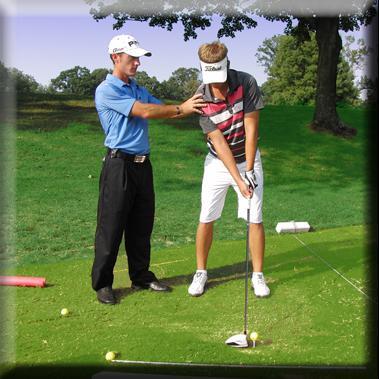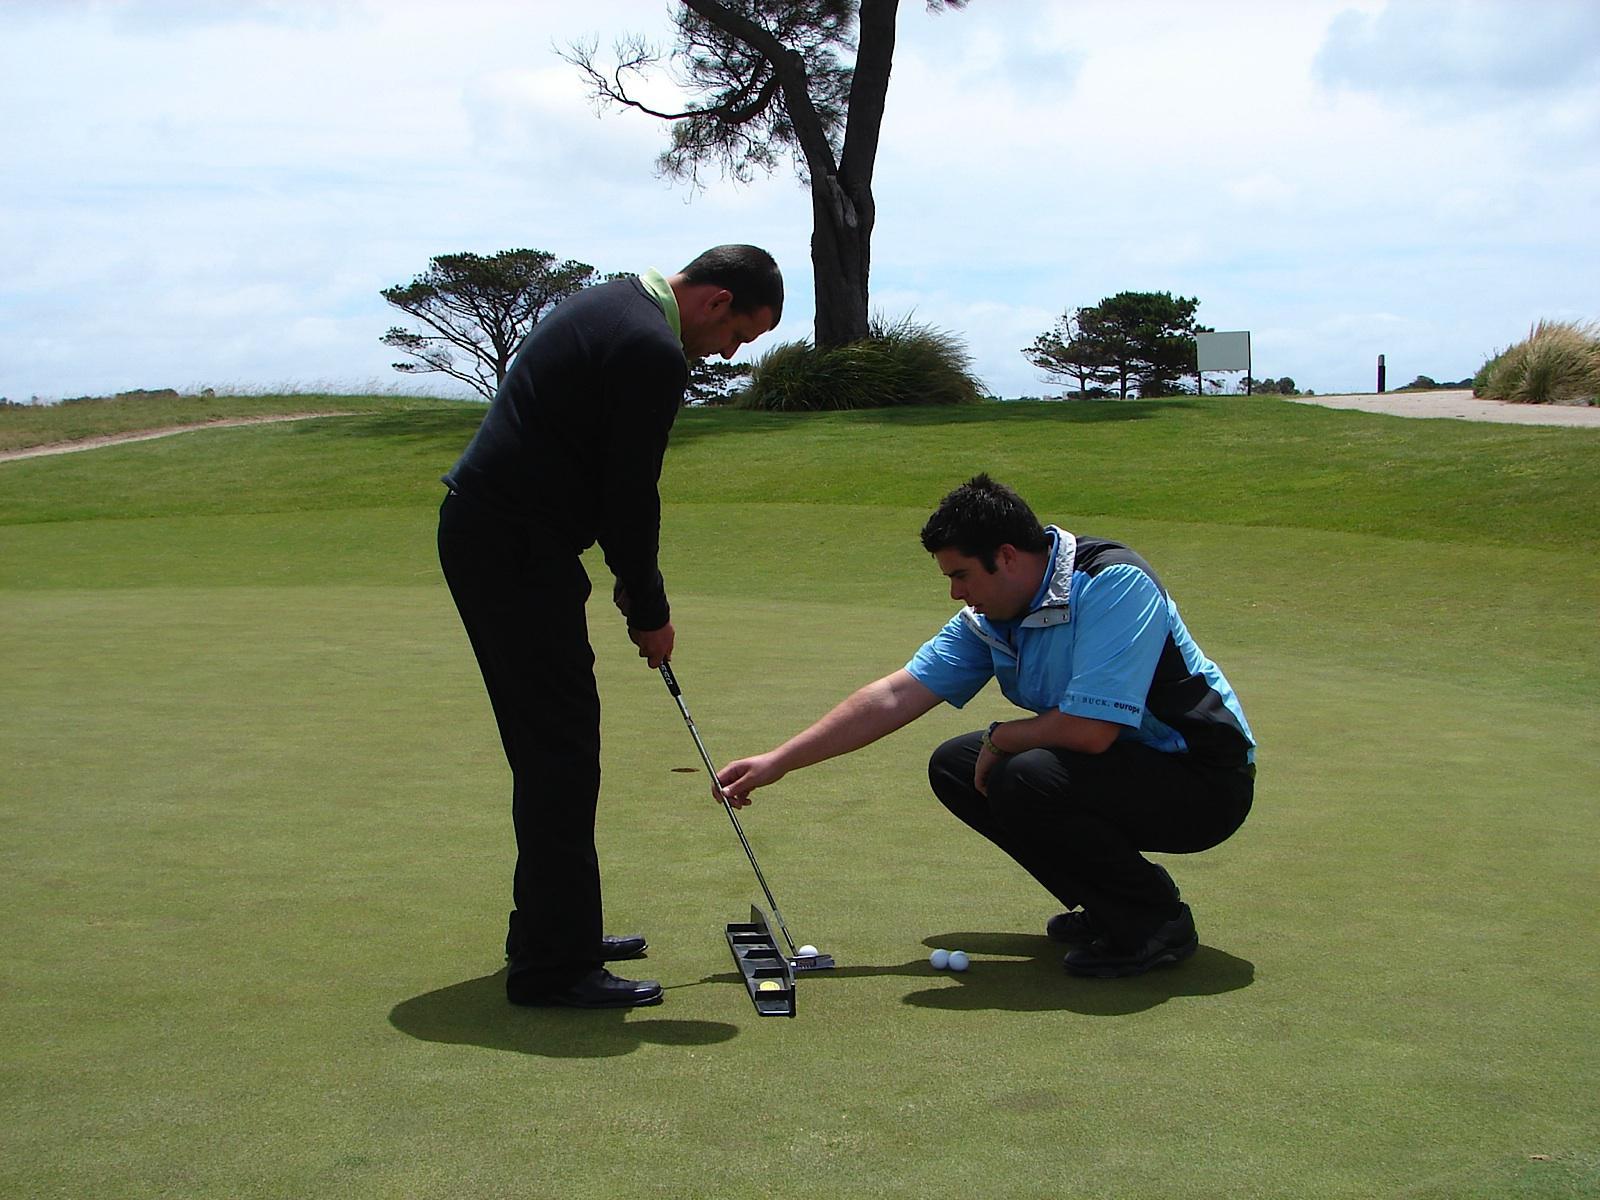The first image is the image on the left, the second image is the image on the right. Evaluate the accuracy of this statement regarding the images: "A man crouches in the grass to the right of a man who is standing and swinging a golf club.". Is it true? Answer yes or no. Yes. The first image is the image on the left, the second image is the image on the right. For the images shown, is this caption "The right image shows one man standing and holding a golf club next to a man crouched down beside him on a golf course" true? Answer yes or no. Yes. 